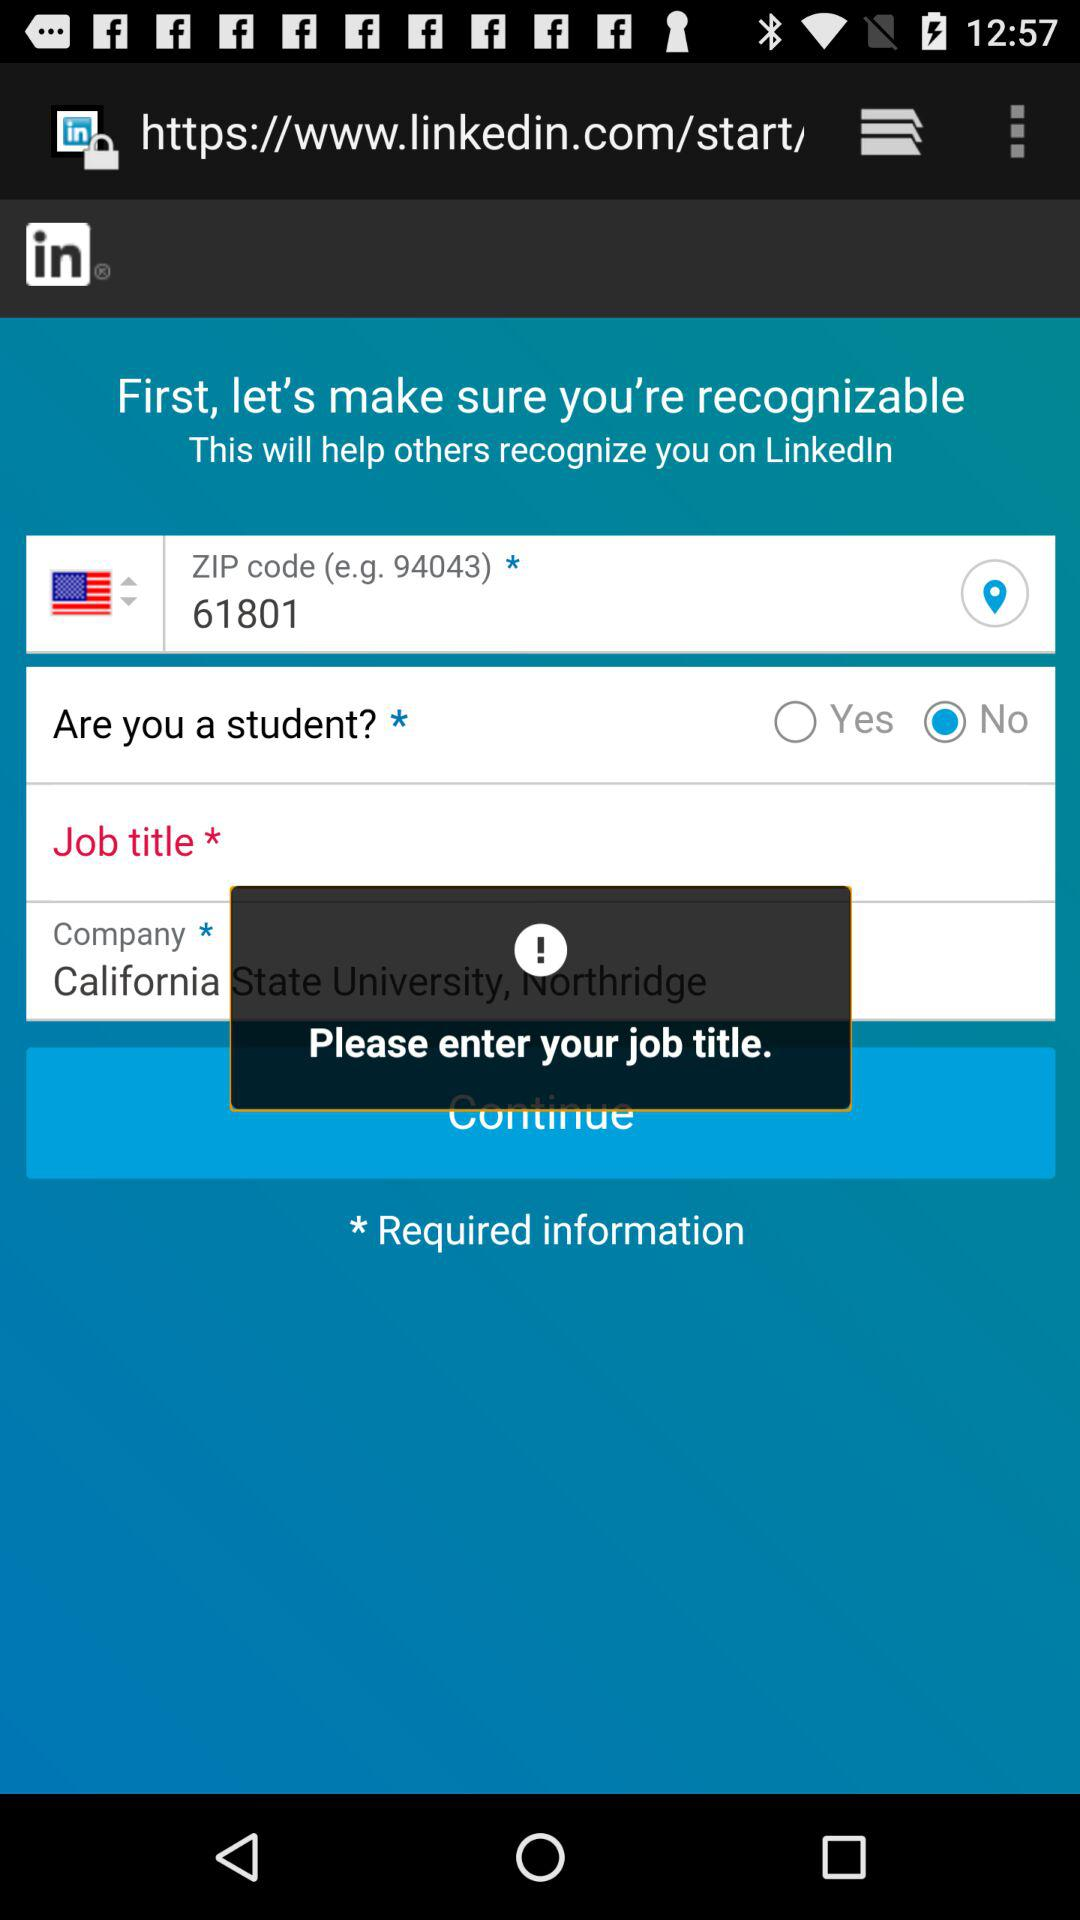Which option has been selected? The option "No" has been selected. 